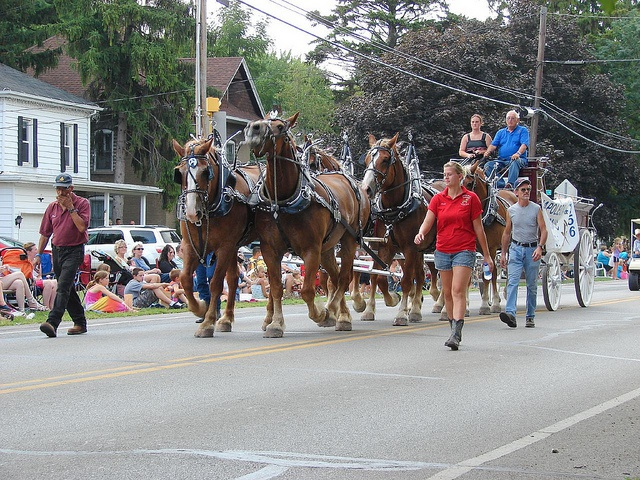Describe the objects in this image and their specific colors. I can see horse in black, maroon, and gray tones, horse in black, maroon, gray, and darkgray tones, horse in black, maroon, gray, and darkgray tones, people in black, brown, and maroon tones, and people in black, brown, maroon, and gray tones in this image. 